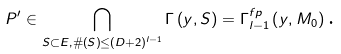Convert formula to latex. <formula><loc_0><loc_0><loc_500><loc_500>P ^ { \prime } \in \bigcap _ { S \subset E , \# \left ( S \right ) \leq \left ( D + 2 \right ) ^ { l - 1 } } \Gamma \left ( y , S \right ) = \Gamma _ { l - 1 } ^ { f p } \left ( y , M _ { 0 } \right ) \text {.}</formula> 